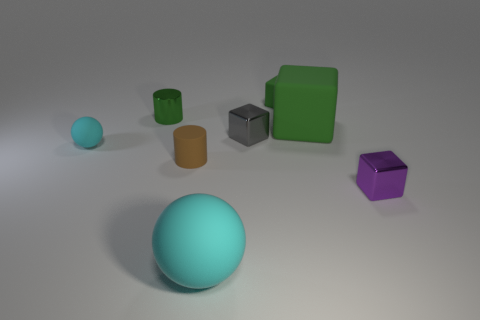Do the tiny rubber thing behind the tiny gray metal block and the large rubber object that is behind the purple cube have the same shape?
Provide a short and direct response. Yes. Are there fewer tiny cylinders that are in front of the tiny gray block than objects in front of the tiny green cylinder?
Keep it short and to the point. Yes. How many other objects are there of the same shape as the small purple thing?
Keep it short and to the point. 3. There is a large green thing that is made of the same material as the brown cylinder; what shape is it?
Keep it short and to the point. Cube. What is the color of the tiny metal object that is to the right of the green cylinder and on the left side of the large block?
Offer a very short reply. Gray. Is the material of the large green block that is on the right side of the brown matte cylinder the same as the small purple block?
Make the answer very short. No. Is the number of tiny objects in front of the green metallic cylinder less than the number of green metallic balls?
Keep it short and to the point. No. Are there any small things that have the same material as the green cylinder?
Make the answer very short. Yes. There is a brown matte cylinder; is it the same size as the rubber object in front of the purple metal cube?
Provide a short and direct response. No. Are there any small metallic cubes that have the same color as the large matte ball?
Make the answer very short. No. 